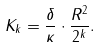<formula> <loc_0><loc_0><loc_500><loc_500>K _ { k } = \frac { \delta } { \kappa } \cdot \frac { R ^ { 2 } } { 2 ^ { k } } .</formula> 